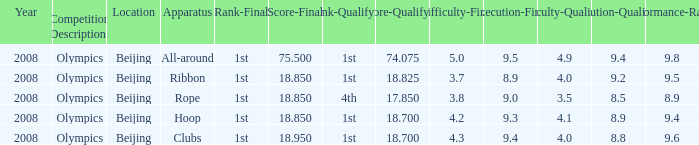What was her final score on the ribbon apparatus? 18.85. 